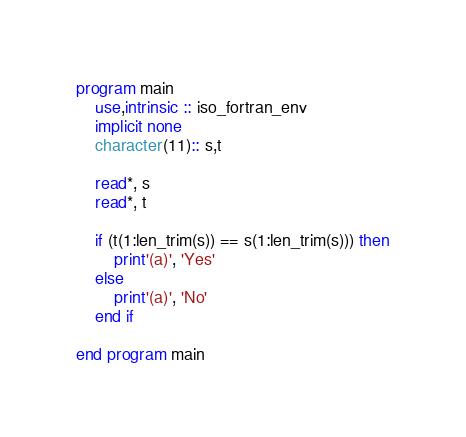<code> <loc_0><loc_0><loc_500><loc_500><_FORTRAN_>program main
    use,intrinsic :: iso_fortran_env
    implicit none
    character(11):: s,t

    read*, s
    read*, t

    if (t(1:len_trim(s)) == s(1:len_trim(s))) then
        print'(a)', 'Yes'
    else
        print'(a)', 'No'
    end if
    
end program main</code> 